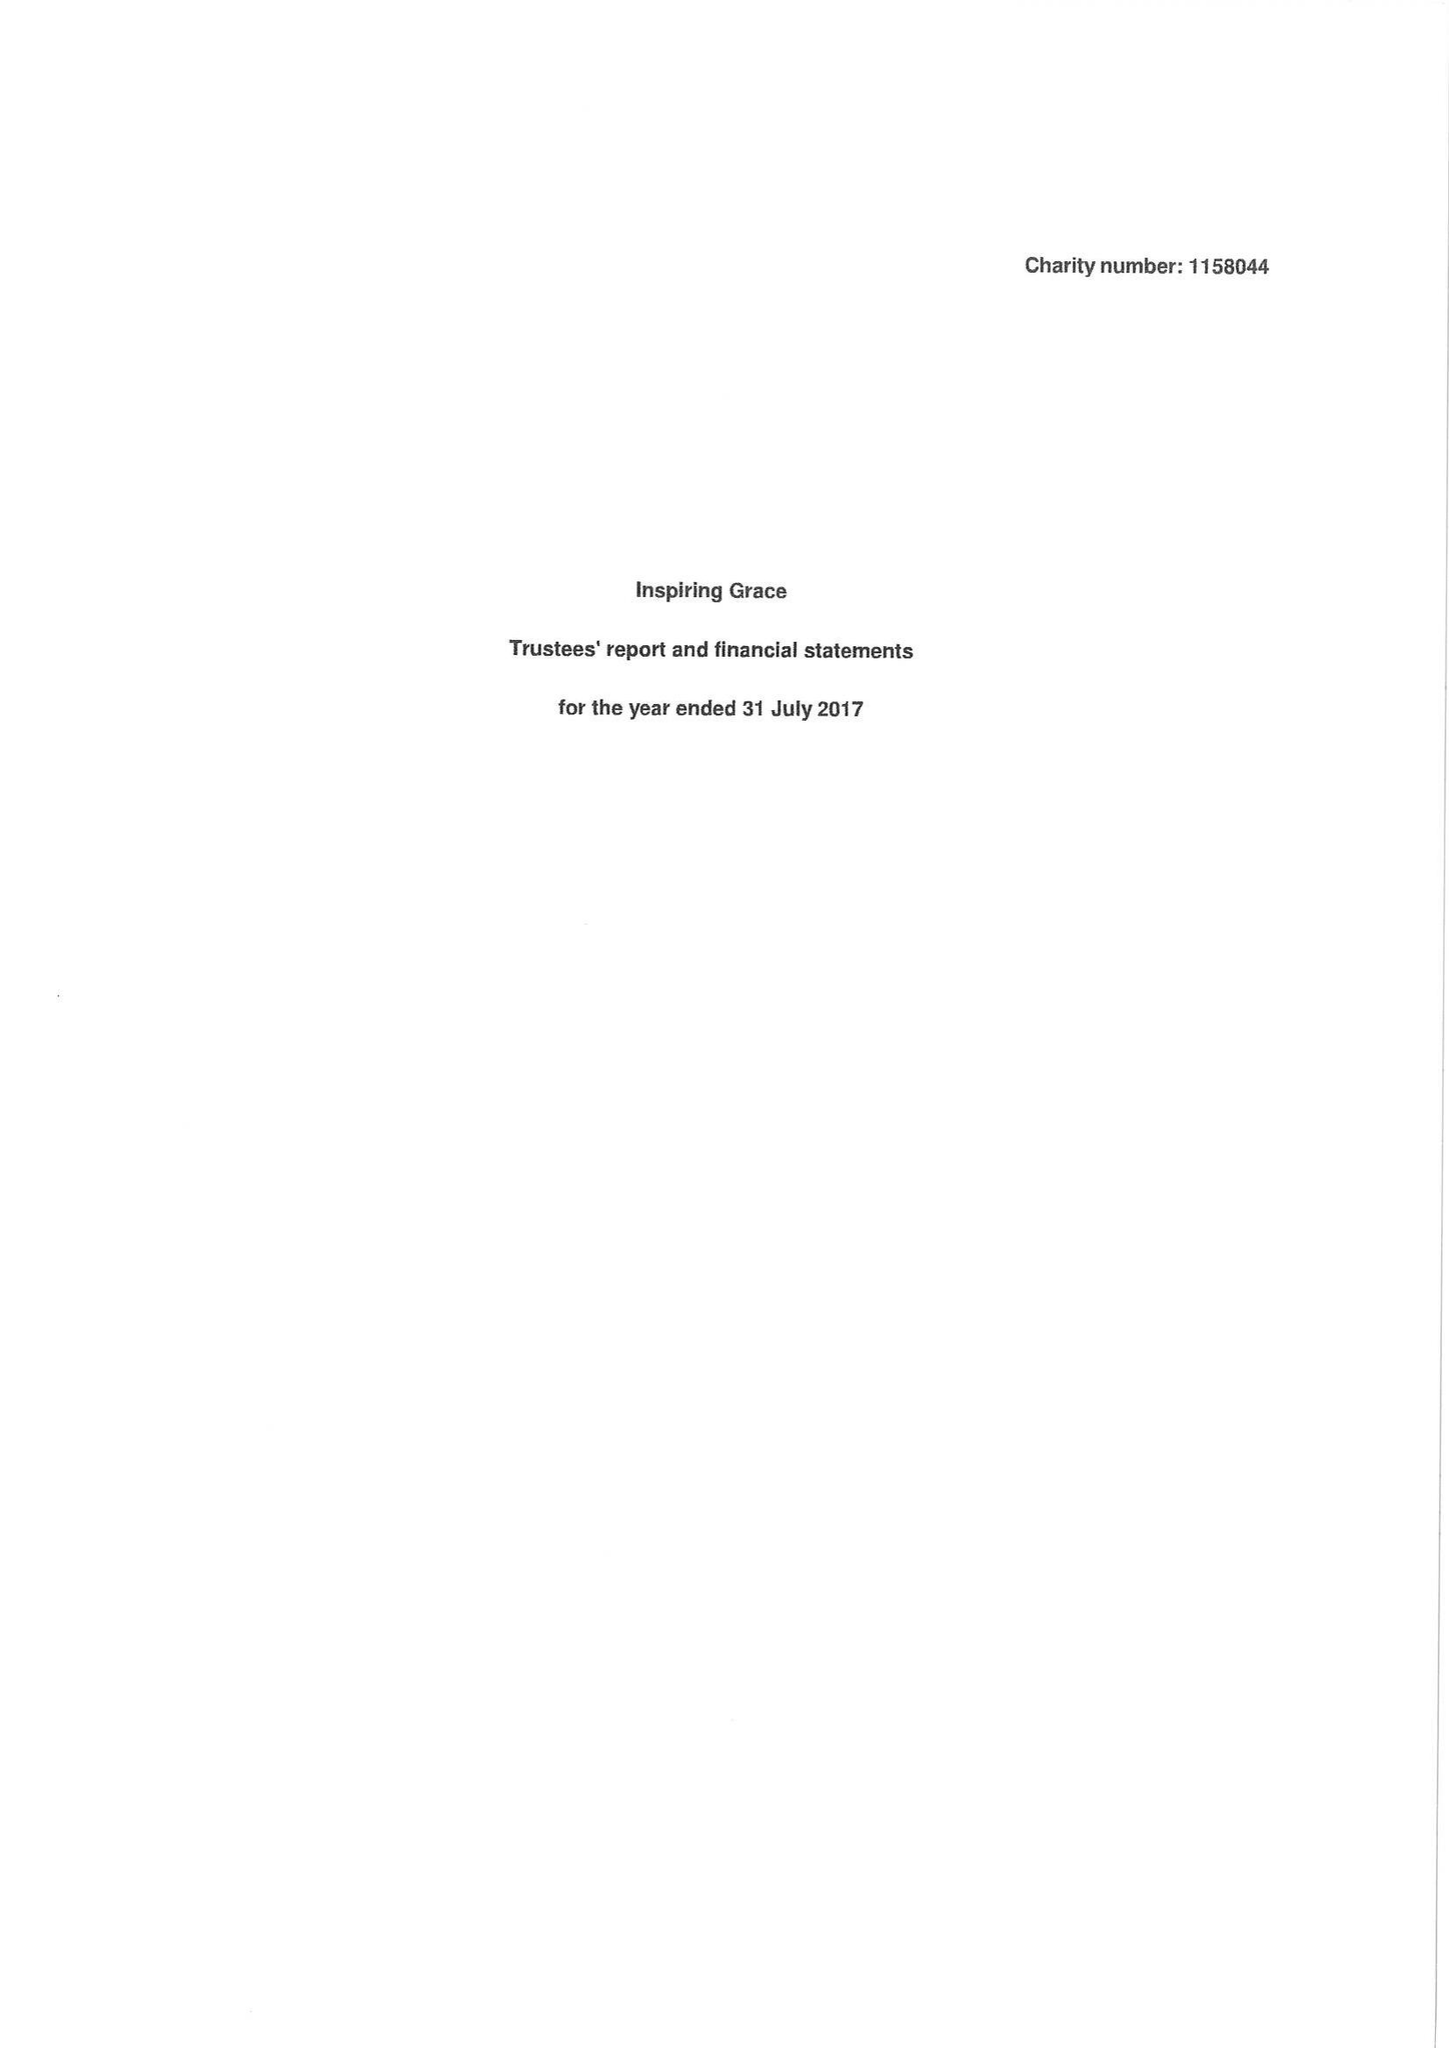What is the value for the income_annually_in_british_pounds?
Answer the question using a single word or phrase. 51660.00 